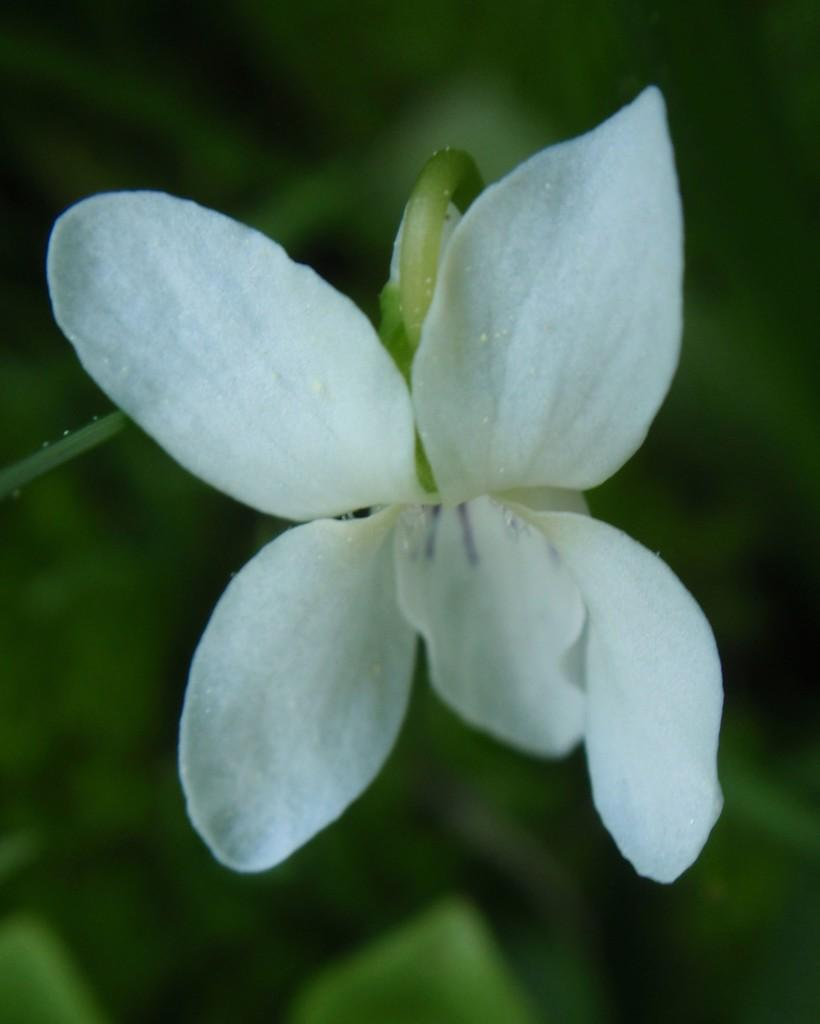What type of flower is in the image? There is a white color flower in the image. Can you describe the background of the image? The background of the image is blurry. What type of pear is hanging from the tree in the image? There is no tree or pear present in the image; it only features a white color flower. How many crows are sitting on the flower in the image? There are no crows present in the image; it only features a white color flower. 